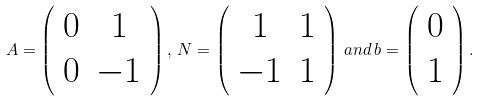Convert formula to latex. <formula><loc_0><loc_0><loc_500><loc_500>A = \left ( \begin{array} { c c } 0 & 1 \\ 0 & - 1 \end{array} \right ) , \, N = \left ( \begin{array} { c c } 1 & 1 \\ - 1 & 1 \end{array} \right ) \, a n d \, b = \left ( \begin{array} { c } 0 \\ 1 \end{array} \right ) .</formula> 